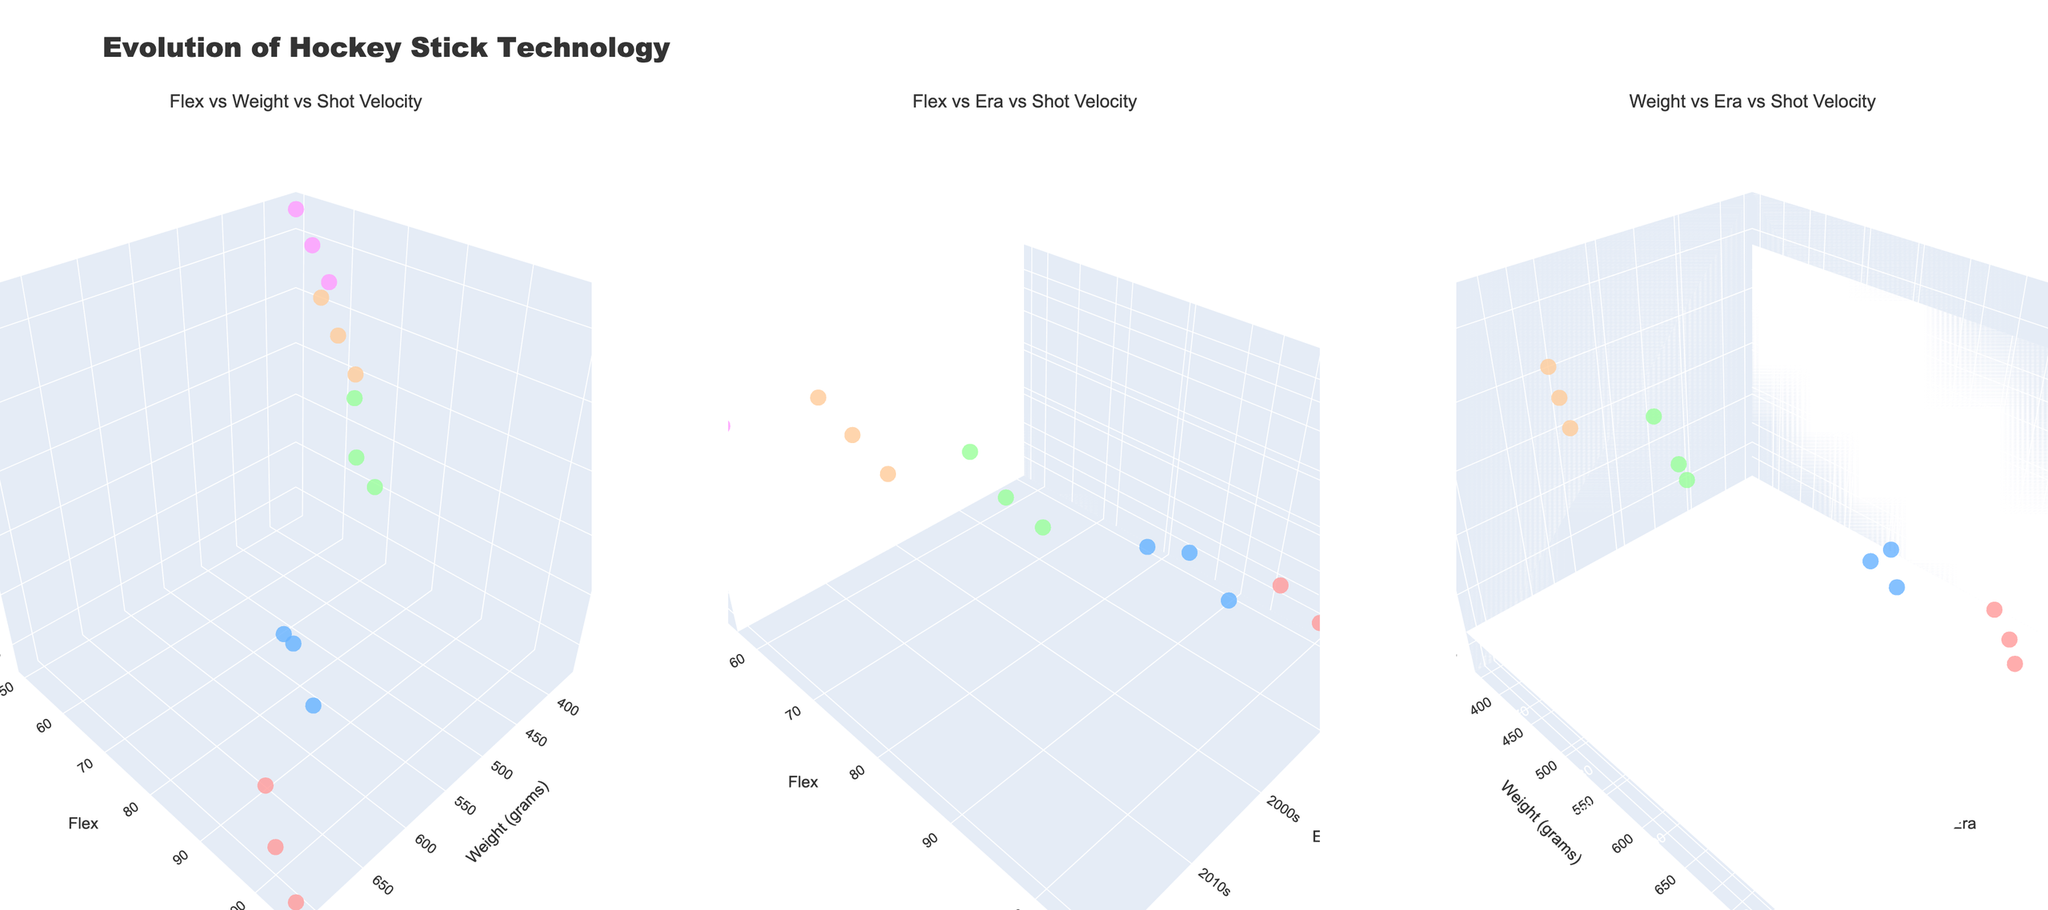What's the title of the chart? The title is shown at the top-center of the figure in a larger and bold font. It summarizes the overall content of the figure.
Answer: Evolution of Hockey Stick Technology How many eras of hockey stick technology are represented in the plots? The eras are distinguishable by color and are listed in the plot legend or through hover text. They are also labeled on the x-axis of two subplots.
Answer: Five Which subplot would you use to compare the changes in shot velocity over different eras? The subplot comparing variables specifically includes "Era" in its axis labels and examines the z-axis for shot velocity.
Answer: Either subplot 2 or 3 What stick from the 2020s has the highest shot velocity? Hover over the data points in the "Weight vs Era vs Shot Velocity" or the "Flex vs Era vs Shot Velocity" plot to identify the stick with the highest shot velocity for the 2020s.
Answer: CCM Jetspeed FT3 Pro From the 1990s to the 2020s, how does the average flex change? Analyze the y-axis (Flex) values for data points from each era and calculate the average for each. Compare the averages.
Answer: Decreases Which stick in the 2000s has the lowest weight? Hover over the data points in any of the subplots where the x-axis or y-axis includes weight and identify the stick from the 2000s with the lowest weight value.
Answer: Bauer Vapor XXX Lite Between the 1980s and 2020s eras, what is the general trend in shot velocity? Compare the z-axis (Shot Velocity) values of the data points between the 1980s and 2020s to observe the trend.
Answer: Increased Is there any era where the flex values are relatively tightly clustered? Evaluate the y-axis values (Flex) for each era individually and identify if any era has data points that are closer together compared to others.
Answer: 2010s Compare the weight of the Bauer Supreme 3000 and the True AX9. Which one is lighter? Hover over the data points to find the name of each stick, then compare their x-axis (Weight) values.
Answer: True AX9 Which stick in the 2010s era recorded the highest shot velocity and what was its value? Hover over the data points in the "Flex vs Era vs Shot Velocity" or "Weight vs Era vs Shot Velocity" subplot to find the stick and note its z-axis value (Shot Velocity).
Answer: CCM RibCor Trigger, 107 mph 